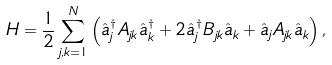Convert formula to latex. <formula><loc_0><loc_0><loc_500><loc_500>H = \frac { 1 } { 2 } \sum _ { j , k = 1 } ^ { N } \left ( \hat { a } ^ { \dagger } _ { j } A _ { j k } \hat { a } ^ { \dagger } _ { k } + 2 \hat { a } ^ { \dagger } _ { j } B _ { j k } \hat { a } _ { k } + \hat { a } _ { j } A _ { j k } \hat { a } _ { k } \right ) ,</formula> 